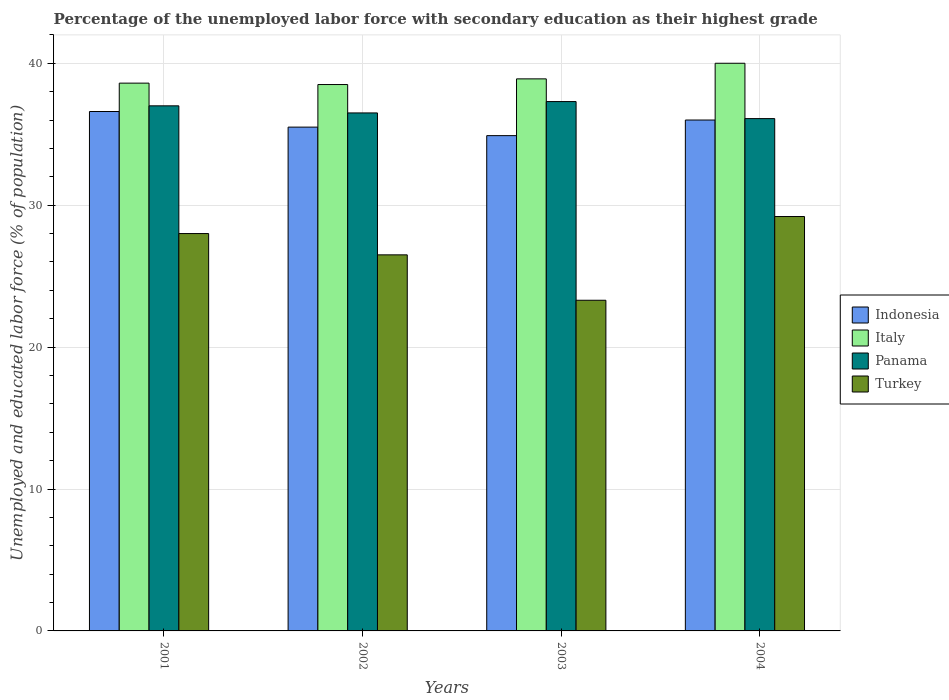How many groups of bars are there?
Your response must be concise. 4. Are the number of bars on each tick of the X-axis equal?
Provide a short and direct response. Yes. How many bars are there on the 2nd tick from the left?
Your answer should be compact. 4. What is the label of the 4th group of bars from the left?
Ensure brevity in your answer.  2004. What is the percentage of the unemployed labor force with secondary education in Indonesia in 2004?
Your response must be concise. 36. Across all years, what is the maximum percentage of the unemployed labor force with secondary education in Panama?
Your answer should be very brief. 37.3. Across all years, what is the minimum percentage of the unemployed labor force with secondary education in Italy?
Your answer should be compact. 38.5. In which year was the percentage of the unemployed labor force with secondary education in Panama maximum?
Your response must be concise. 2003. What is the total percentage of the unemployed labor force with secondary education in Indonesia in the graph?
Provide a short and direct response. 143. What is the difference between the percentage of the unemployed labor force with secondary education in Italy in 2002 and that in 2004?
Keep it short and to the point. -1.5. What is the difference between the percentage of the unemployed labor force with secondary education in Italy in 2003 and the percentage of the unemployed labor force with secondary education in Panama in 2002?
Provide a succinct answer. 2.4. What is the average percentage of the unemployed labor force with secondary education in Indonesia per year?
Ensure brevity in your answer.  35.75. In the year 2004, what is the difference between the percentage of the unemployed labor force with secondary education in Indonesia and percentage of the unemployed labor force with secondary education in Panama?
Your response must be concise. -0.1. In how many years, is the percentage of the unemployed labor force with secondary education in Italy greater than 38 %?
Your answer should be very brief. 4. What is the ratio of the percentage of the unemployed labor force with secondary education in Indonesia in 2001 to that in 2002?
Provide a short and direct response. 1.03. Is the percentage of the unemployed labor force with secondary education in Turkey in 2001 less than that in 2003?
Your answer should be compact. No. Is the difference between the percentage of the unemployed labor force with secondary education in Indonesia in 2001 and 2003 greater than the difference between the percentage of the unemployed labor force with secondary education in Panama in 2001 and 2003?
Your response must be concise. Yes. What is the difference between the highest and the second highest percentage of the unemployed labor force with secondary education in Italy?
Offer a very short reply. 1.1. In how many years, is the percentage of the unemployed labor force with secondary education in Indonesia greater than the average percentage of the unemployed labor force with secondary education in Indonesia taken over all years?
Make the answer very short. 2. What does the 2nd bar from the left in 2004 represents?
Your answer should be very brief. Italy. How many years are there in the graph?
Your answer should be compact. 4. Does the graph contain any zero values?
Your answer should be very brief. No. How many legend labels are there?
Provide a succinct answer. 4. How are the legend labels stacked?
Keep it short and to the point. Vertical. What is the title of the graph?
Offer a very short reply. Percentage of the unemployed labor force with secondary education as their highest grade. Does "Iceland" appear as one of the legend labels in the graph?
Provide a short and direct response. No. What is the label or title of the Y-axis?
Offer a terse response. Unemployed and educated labor force (% of population). What is the Unemployed and educated labor force (% of population) in Indonesia in 2001?
Your answer should be very brief. 36.6. What is the Unemployed and educated labor force (% of population) in Italy in 2001?
Give a very brief answer. 38.6. What is the Unemployed and educated labor force (% of population) in Turkey in 2001?
Your response must be concise. 28. What is the Unemployed and educated labor force (% of population) in Indonesia in 2002?
Ensure brevity in your answer.  35.5. What is the Unemployed and educated labor force (% of population) in Italy in 2002?
Your answer should be very brief. 38.5. What is the Unemployed and educated labor force (% of population) in Panama in 2002?
Ensure brevity in your answer.  36.5. What is the Unemployed and educated labor force (% of population) in Turkey in 2002?
Give a very brief answer. 26.5. What is the Unemployed and educated labor force (% of population) of Indonesia in 2003?
Provide a short and direct response. 34.9. What is the Unemployed and educated labor force (% of population) of Italy in 2003?
Offer a terse response. 38.9. What is the Unemployed and educated labor force (% of population) in Panama in 2003?
Offer a very short reply. 37.3. What is the Unemployed and educated labor force (% of population) in Turkey in 2003?
Provide a short and direct response. 23.3. What is the Unemployed and educated labor force (% of population) in Italy in 2004?
Your answer should be compact. 40. What is the Unemployed and educated labor force (% of population) in Panama in 2004?
Your answer should be compact. 36.1. What is the Unemployed and educated labor force (% of population) in Turkey in 2004?
Give a very brief answer. 29.2. Across all years, what is the maximum Unemployed and educated labor force (% of population) in Indonesia?
Offer a very short reply. 36.6. Across all years, what is the maximum Unemployed and educated labor force (% of population) of Panama?
Offer a very short reply. 37.3. Across all years, what is the maximum Unemployed and educated labor force (% of population) in Turkey?
Offer a terse response. 29.2. Across all years, what is the minimum Unemployed and educated labor force (% of population) in Indonesia?
Provide a succinct answer. 34.9. Across all years, what is the minimum Unemployed and educated labor force (% of population) of Italy?
Offer a terse response. 38.5. Across all years, what is the minimum Unemployed and educated labor force (% of population) in Panama?
Provide a succinct answer. 36.1. Across all years, what is the minimum Unemployed and educated labor force (% of population) of Turkey?
Offer a very short reply. 23.3. What is the total Unemployed and educated labor force (% of population) in Indonesia in the graph?
Provide a short and direct response. 143. What is the total Unemployed and educated labor force (% of population) in Italy in the graph?
Keep it short and to the point. 156. What is the total Unemployed and educated labor force (% of population) of Panama in the graph?
Offer a terse response. 146.9. What is the total Unemployed and educated labor force (% of population) of Turkey in the graph?
Provide a short and direct response. 107. What is the difference between the Unemployed and educated labor force (% of population) in Indonesia in 2001 and that in 2002?
Your answer should be compact. 1.1. What is the difference between the Unemployed and educated labor force (% of population) of Italy in 2001 and that in 2002?
Provide a short and direct response. 0.1. What is the difference between the Unemployed and educated labor force (% of population) of Panama in 2001 and that in 2002?
Your answer should be compact. 0.5. What is the difference between the Unemployed and educated labor force (% of population) of Italy in 2001 and that in 2003?
Keep it short and to the point. -0.3. What is the difference between the Unemployed and educated labor force (% of population) in Indonesia in 2001 and that in 2004?
Provide a succinct answer. 0.6. What is the difference between the Unemployed and educated labor force (% of population) in Turkey in 2001 and that in 2004?
Make the answer very short. -1.2. What is the difference between the Unemployed and educated labor force (% of population) in Indonesia in 2002 and that in 2003?
Provide a short and direct response. 0.6. What is the difference between the Unemployed and educated labor force (% of population) in Panama in 2002 and that in 2003?
Offer a terse response. -0.8. What is the difference between the Unemployed and educated labor force (% of population) of Turkey in 2002 and that in 2003?
Your answer should be very brief. 3.2. What is the difference between the Unemployed and educated labor force (% of population) in Italy in 2002 and that in 2004?
Provide a succinct answer. -1.5. What is the difference between the Unemployed and educated labor force (% of population) in Turkey in 2002 and that in 2004?
Your answer should be compact. -2.7. What is the difference between the Unemployed and educated labor force (% of population) of Panama in 2003 and that in 2004?
Provide a short and direct response. 1.2. What is the difference between the Unemployed and educated labor force (% of population) of Indonesia in 2001 and the Unemployed and educated labor force (% of population) of Panama in 2002?
Ensure brevity in your answer.  0.1. What is the difference between the Unemployed and educated labor force (% of population) of Italy in 2001 and the Unemployed and educated labor force (% of population) of Turkey in 2002?
Your response must be concise. 12.1. What is the difference between the Unemployed and educated labor force (% of population) of Panama in 2001 and the Unemployed and educated labor force (% of population) of Turkey in 2002?
Offer a very short reply. 10.5. What is the difference between the Unemployed and educated labor force (% of population) in Indonesia in 2001 and the Unemployed and educated labor force (% of population) in Turkey in 2003?
Your answer should be very brief. 13.3. What is the difference between the Unemployed and educated labor force (% of population) of Italy in 2001 and the Unemployed and educated labor force (% of population) of Panama in 2003?
Provide a succinct answer. 1.3. What is the difference between the Unemployed and educated labor force (% of population) in Italy in 2001 and the Unemployed and educated labor force (% of population) in Turkey in 2003?
Make the answer very short. 15.3. What is the difference between the Unemployed and educated labor force (% of population) in Indonesia in 2001 and the Unemployed and educated labor force (% of population) in Panama in 2004?
Offer a very short reply. 0.5. What is the difference between the Unemployed and educated labor force (% of population) in Indonesia in 2001 and the Unemployed and educated labor force (% of population) in Turkey in 2004?
Your response must be concise. 7.4. What is the difference between the Unemployed and educated labor force (% of population) in Italy in 2001 and the Unemployed and educated labor force (% of population) in Panama in 2004?
Keep it short and to the point. 2.5. What is the difference between the Unemployed and educated labor force (% of population) in Indonesia in 2002 and the Unemployed and educated labor force (% of population) in Italy in 2003?
Your answer should be very brief. -3.4. What is the difference between the Unemployed and educated labor force (% of population) of Indonesia in 2002 and the Unemployed and educated labor force (% of population) of Panama in 2003?
Provide a short and direct response. -1.8. What is the difference between the Unemployed and educated labor force (% of population) of Italy in 2002 and the Unemployed and educated labor force (% of population) of Panama in 2003?
Offer a terse response. 1.2. What is the difference between the Unemployed and educated labor force (% of population) of Italy in 2002 and the Unemployed and educated labor force (% of population) of Turkey in 2003?
Keep it short and to the point. 15.2. What is the difference between the Unemployed and educated labor force (% of population) of Indonesia in 2002 and the Unemployed and educated labor force (% of population) of Italy in 2004?
Offer a terse response. -4.5. What is the difference between the Unemployed and educated labor force (% of population) in Indonesia in 2002 and the Unemployed and educated labor force (% of population) in Turkey in 2004?
Give a very brief answer. 6.3. What is the difference between the Unemployed and educated labor force (% of population) in Italy in 2002 and the Unemployed and educated labor force (% of population) in Panama in 2004?
Offer a very short reply. 2.4. What is the difference between the Unemployed and educated labor force (% of population) of Italy in 2002 and the Unemployed and educated labor force (% of population) of Turkey in 2004?
Provide a succinct answer. 9.3. What is the difference between the Unemployed and educated labor force (% of population) in Italy in 2003 and the Unemployed and educated labor force (% of population) in Turkey in 2004?
Keep it short and to the point. 9.7. What is the average Unemployed and educated labor force (% of population) in Indonesia per year?
Your answer should be very brief. 35.75. What is the average Unemployed and educated labor force (% of population) in Italy per year?
Offer a terse response. 39. What is the average Unemployed and educated labor force (% of population) of Panama per year?
Give a very brief answer. 36.73. What is the average Unemployed and educated labor force (% of population) in Turkey per year?
Provide a short and direct response. 26.75. In the year 2001, what is the difference between the Unemployed and educated labor force (% of population) of Indonesia and Unemployed and educated labor force (% of population) of Italy?
Provide a succinct answer. -2. In the year 2001, what is the difference between the Unemployed and educated labor force (% of population) of Indonesia and Unemployed and educated labor force (% of population) of Turkey?
Your answer should be very brief. 8.6. In the year 2001, what is the difference between the Unemployed and educated labor force (% of population) of Italy and Unemployed and educated labor force (% of population) of Panama?
Give a very brief answer. 1.6. In the year 2001, what is the difference between the Unemployed and educated labor force (% of population) in Italy and Unemployed and educated labor force (% of population) in Turkey?
Provide a short and direct response. 10.6. In the year 2002, what is the difference between the Unemployed and educated labor force (% of population) of Indonesia and Unemployed and educated labor force (% of population) of Italy?
Your response must be concise. -3. In the year 2002, what is the difference between the Unemployed and educated labor force (% of population) of Indonesia and Unemployed and educated labor force (% of population) of Panama?
Give a very brief answer. -1. In the year 2002, what is the difference between the Unemployed and educated labor force (% of population) of Italy and Unemployed and educated labor force (% of population) of Panama?
Ensure brevity in your answer.  2. In the year 2002, what is the difference between the Unemployed and educated labor force (% of population) of Italy and Unemployed and educated labor force (% of population) of Turkey?
Provide a short and direct response. 12. In the year 2003, what is the difference between the Unemployed and educated labor force (% of population) of Indonesia and Unemployed and educated labor force (% of population) of Italy?
Your answer should be compact. -4. In the year 2003, what is the difference between the Unemployed and educated labor force (% of population) of Indonesia and Unemployed and educated labor force (% of population) of Panama?
Your response must be concise. -2.4. In the year 2003, what is the difference between the Unemployed and educated labor force (% of population) of Italy and Unemployed and educated labor force (% of population) of Panama?
Provide a succinct answer. 1.6. In the year 2003, what is the difference between the Unemployed and educated labor force (% of population) of Italy and Unemployed and educated labor force (% of population) of Turkey?
Your answer should be very brief. 15.6. In the year 2003, what is the difference between the Unemployed and educated labor force (% of population) in Panama and Unemployed and educated labor force (% of population) in Turkey?
Ensure brevity in your answer.  14. In the year 2004, what is the difference between the Unemployed and educated labor force (% of population) in Indonesia and Unemployed and educated labor force (% of population) in Italy?
Your response must be concise. -4. In the year 2004, what is the difference between the Unemployed and educated labor force (% of population) in Indonesia and Unemployed and educated labor force (% of population) in Turkey?
Keep it short and to the point. 6.8. In the year 2004, what is the difference between the Unemployed and educated labor force (% of population) of Italy and Unemployed and educated labor force (% of population) of Turkey?
Keep it short and to the point. 10.8. What is the ratio of the Unemployed and educated labor force (% of population) in Indonesia in 2001 to that in 2002?
Your answer should be compact. 1.03. What is the ratio of the Unemployed and educated labor force (% of population) in Panama in 2001 to that in 2002?
Keep it short and to the point. 1.01. What is the ratio of the Unemployed and educated labor force (% of population) of Turkey in 2001 to that in 2002?
Make the answer very short. 1.06. What is the ratio of the Unemployed and educated labor force (% of population) of Indonesia in 2001 to that in 2003?
Offer a very short reply. 1.05. What is the ratio of the Unemployed and educated labor force (% of population) in Italy in 2001 to that in 2003?
Your answer should be very brief. 0.99. What is the ratio of the Unemployed and educated labor force (% of population) of Turkey in 2001 to that in 2003?
Provide a succinct answer. 1.2. What is the ratio of the Unemployed and educated labor force (% of population) of Indonesia in 2001 to that in 2004?
Your response must be concise. 1.02. What is the ratio of the Unemployed and educated labor force (% of population) of Italy in 2001 to that in 2004?
Your answer should be compact. 0.96. What is the ratio of the Unemployed and educated labor force (% of population) of Panama in 2001 to that in 2004?
Make the answer very short. 1.02. What is the ratio of the Unemployed and educated labor force (% of population) in Turkey in 2001 to that in 2004?
Your response must be concise. 0.96. What is the ratio of the Unemployed and educated labor force (% of population) of Indonesia in 2002 to that in 2003?
Keep it short and to the point. 1.02. What is the ratio of the Unemployed and educated labor force (% of population) of Panama in 2002 to that in 2003?
Offer a very short reply. 0.98. What is the ratio of the Unemployed and educated labor force (% of population) of Turkey in 2002 to that in 2003?
Keep it short and to the point. 1.14. What is the ratio of the Unemployed and educated labor force (% of population) in Indonesia in 2002 to that in 2004?
Offer a very short reply. 0.99. What is the ratio of the Unemployed and educated labor force (% of population) of Italy in 2002 to that in 2004?
Your answer should be compact. 0.96. What is the ratio of the Unemployed and educated labor force (% of population) in Panama in 2002 to that in 2004?
Offer a very short reply. 1.01. What is the ratio of the Unemployed and educated labor force (% of population) in Turkey in 2002 to that in 2004?
Give a very brief answer. 0.91. What is the ratio of the Unemployed and educated labor force (% of population) of Indonesia in 2003 to that in 2004?
Offer a very short reply. 0.97. What is the ratio of the Unemployed and educated labor force (% of population) of Italy in 2003 to that in 2004?
Ensure brevity in your answer.  0.97. What is the ratio of the Unemployed and educated labor force (% of population) of Panama in 2003 to that in 2004?
Offer a very short reply. 1.03. What is the ratio of the Unemployed and educated labor force (% of population) of Turkey in 2003 to that in 2004?
Your response must be concise. 0.8. What is the difference between the highest and the second highest Unemployed and educated labor force (% of population) of Italy?
Your answer should be very brief. 1.1. What is the difference between the highest and the second highest Unemployed and educated labor force (% of population) in Panama?
Make the answer very short. 0.3. What is the difference between the highest and the second highest Unemployed and educated labor force (% of population) of Turkey?
Give a very brief answer. 1.2. What is the difference between the highest and the lowest Unemployed and educated labor force (% of population) in Indonesia?
Offer a terse response. 1.7. What is the difference between the highest and the lowest Unemployed and educated labor force (% of population) in Turkey?
Provide a succinct answer. 5.9. 